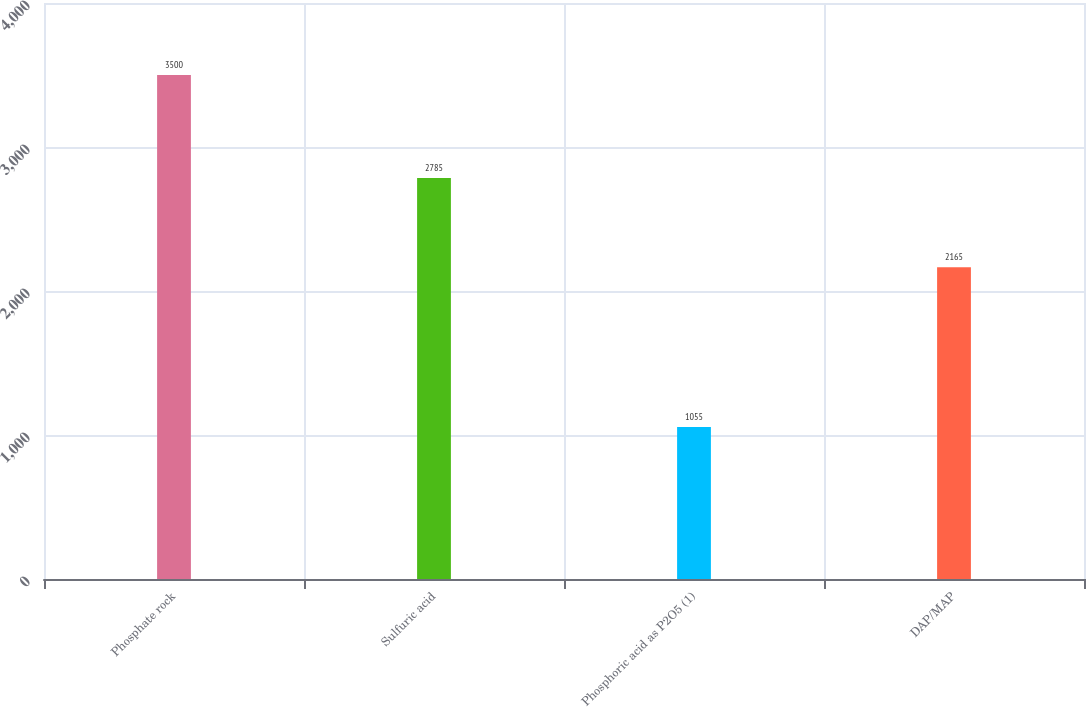Convert chart to OTSL. <chart><loc_0><loc_0><loc_500><loc_500><bar_chart><fcel>Phosphate rock<fcel>Sulfuric acid<fcel>Phosphoric acid as P2O5 (1)<fcel>DAP/MAP<nl><fcel>3500<fcel>2785<fcel>1055<fcel>2165<nl></chart> 